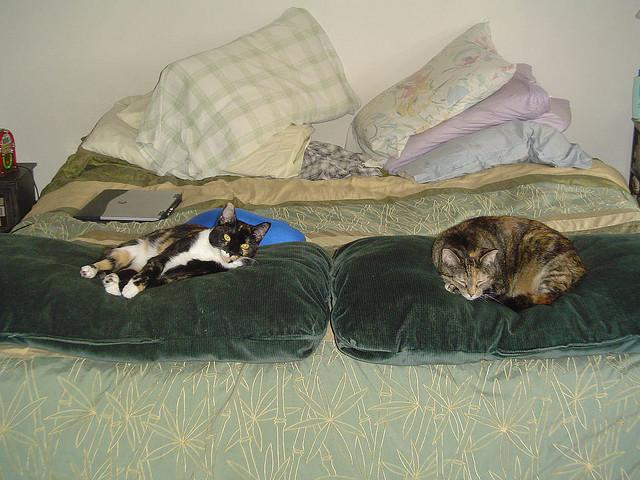How many cats are on pillows?

Choices:
A) two
B) six
C) eight
D) four two 